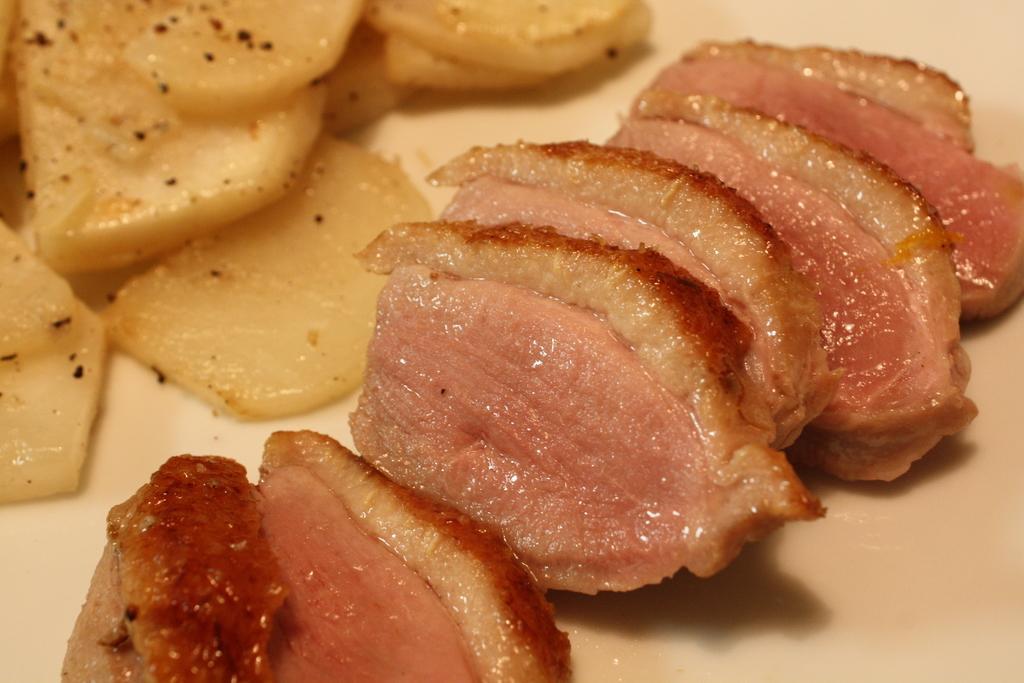Describe this image in one or two sentences. We can see food on the surface. 